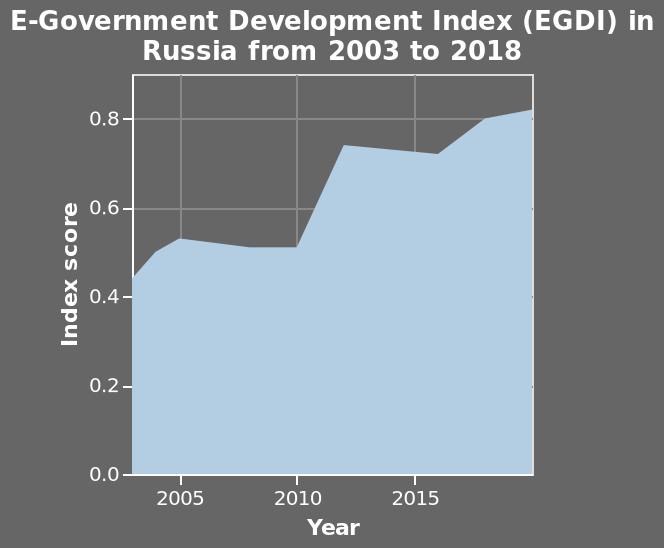<image>
What has been the trend in the E-Government Development Index (EGDI) in Russia from 2003 to 2018? The EGDI in Russia has shown notable growth from 2003 to 2018, almost doubling in those years. please enumerates aspects of the construction of the chart This area plot is named E-Government Development Index (EGDI) in Russia from 2003 to 2018. The y-axis shows Index score. The x-axis plots Year with a linear scale from 2005 to 2015. 